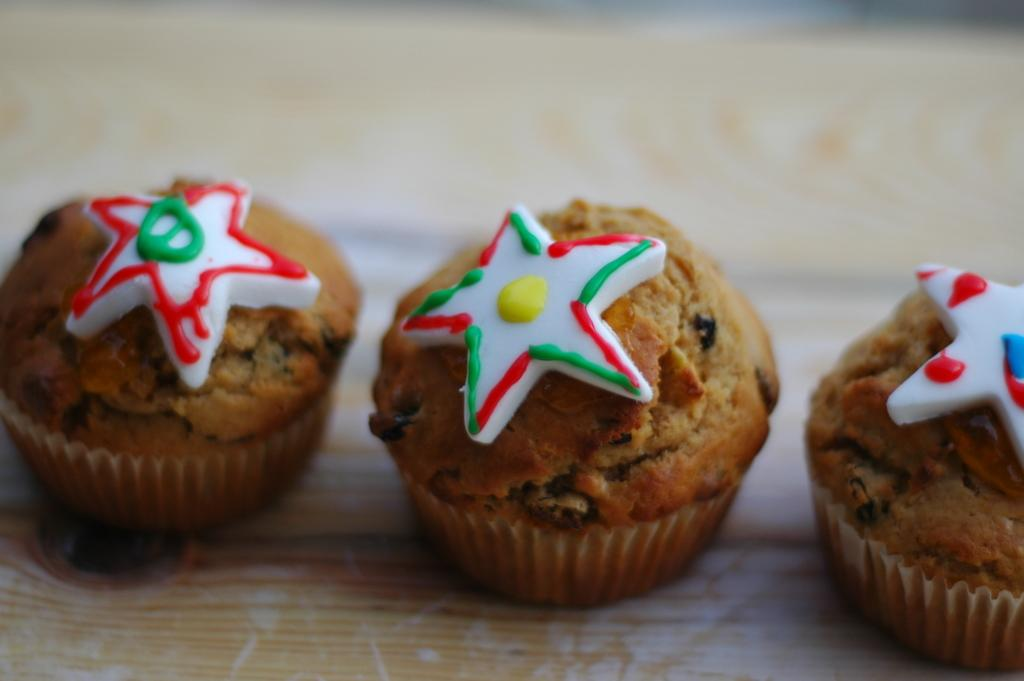What is the person holding in the image? The person is holding a book and a pen. What is the person doing with the book and pen? The person is likely reading or writing with the book and pen. Where is the person sitting in the image? The person is sitting on a chair. What type of wing is visible on the person in the image? There is no wing visible on the person in the image. Can you describe the intricate details of the pen in the image? The provided facts do not mention any specific details about the pen, so we cannot describe its intricate details. 